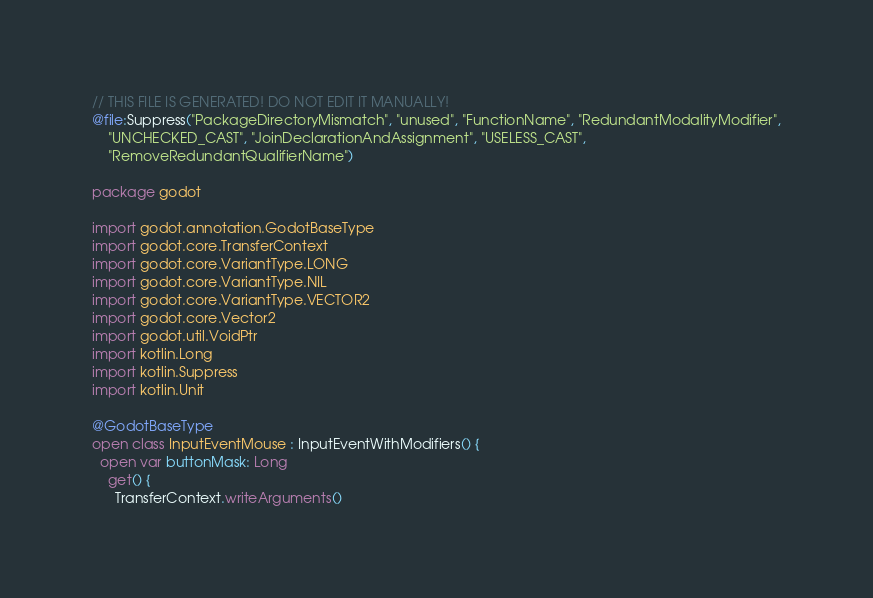<code> <loc_0><loc_0><loc_500><loc_500><_Kotlin_>// THIS FILE IS GENERATED! DO NOT EDIT IT MANUALLY!
@file:Suppress("PackageDirectoryMismatch", "unused", "FunctionName", "RedundantModalityModifier",
    "UNCHECKED_CAST", "JoinDeclarationAndAssignment", "USELESS_CAST",
    "RemoveRedundantQualifierName")

package godot

import godot.annotation.GodotBaseType
import godot.core.TransferContext
import godot.core.VariantType.LONG
import godot.core.VariantType.NIL
import godot.core.VariantType.VECTOR2
import godot.core.Vector2
import godot.util.VoidPtr
import kotlin.Long
import kotlin.Suppress
import kotlin.Unit

@GodotBaseType
open class InputEventMouse : InputEventWithModifiers() {
  open var buttonMask: Long
    get() {
      TransferContext.writeArguments()</code> 